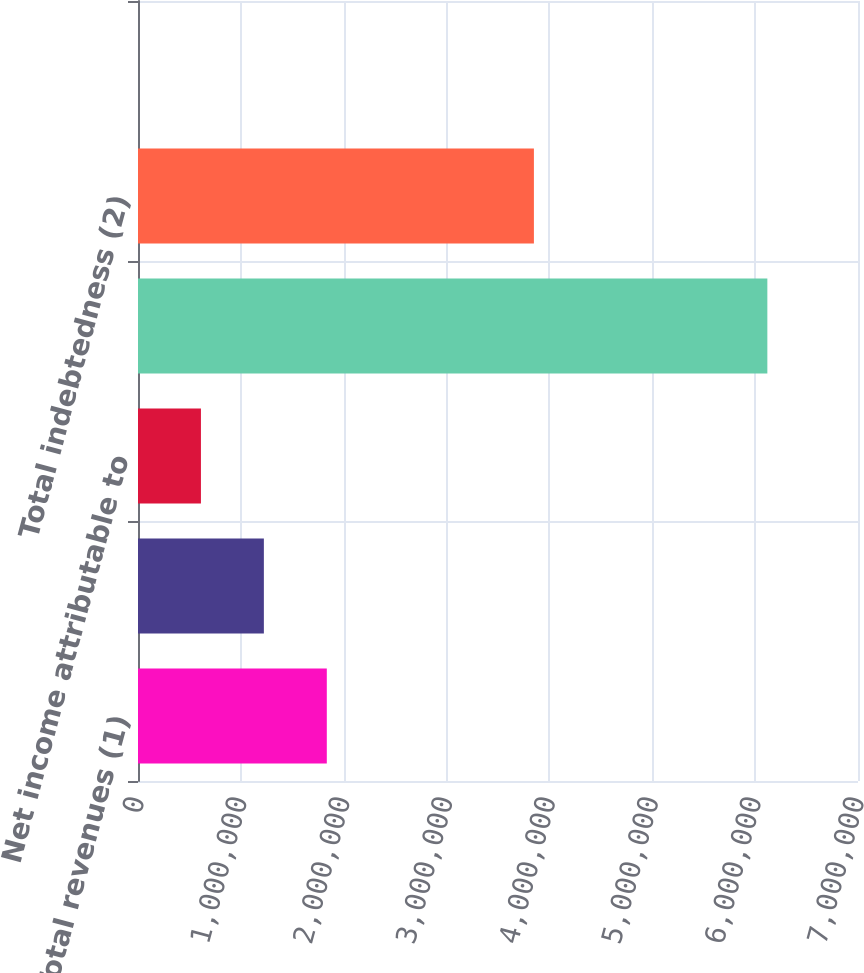Convert chart to OTSL. <chart><loc_0><loc_0><loc_500><loc_500><bar_chart><fcel>Total revenues (1)<fcel>Net income (1)<fcel>Net income attributable to<fcel>Total assets (2)<fcel>Total indebtedness (2)<fcel>Dividends/distributions<nl><fcel>1.83561e+06<fcel>1.22374e+06<fcel>611869<fcel>6.11868e+06<fcel>3.84914e+06<fcel>1.18<nl></chart> 